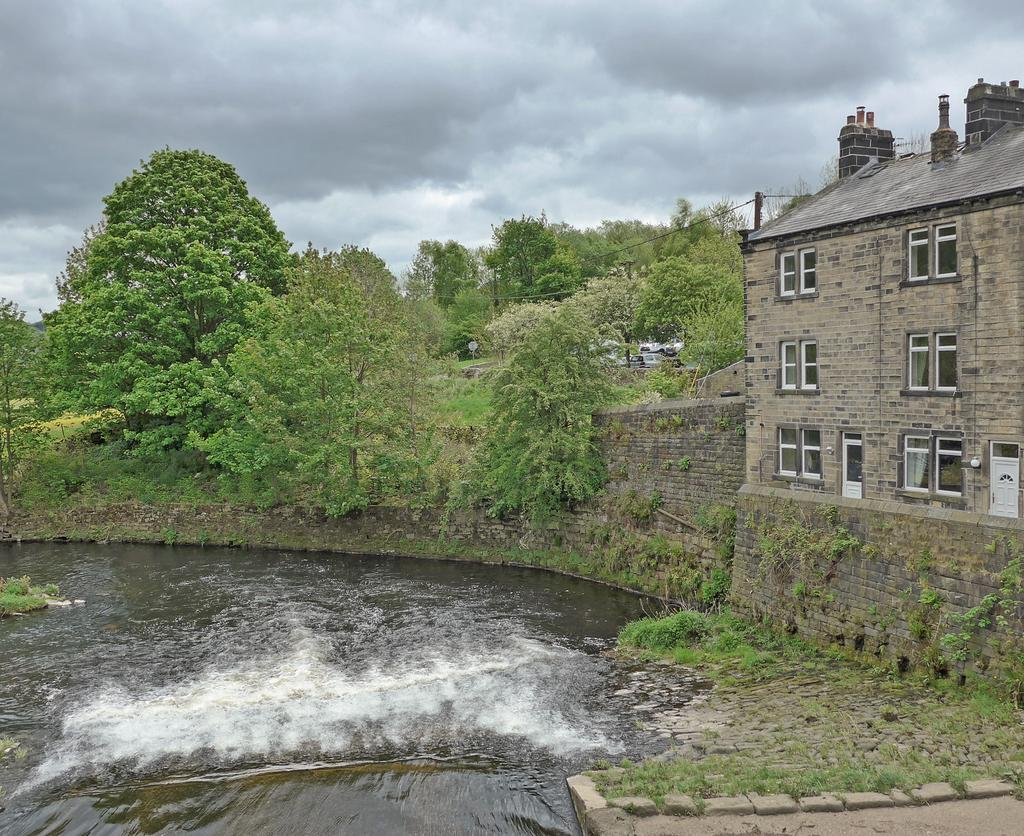What is one of the natural elements present in the image? There is water in the image. What type of vegetation can be seen in the image? There is grass in the image. What type of structure is visible in the image? There is a house in the image. What other type of vegetation is present in the image? There are trees in the image. What can be seen in the background of the image? The sky is visible in the background of the image. What type of collar can be seen on the trees in the image? There are no collars present on the trees in the image; they are natural trees. What type of pan is being used to cook the grass in the image? There is no pan or cooking activity present in the image; the grass is natural vegetation. 